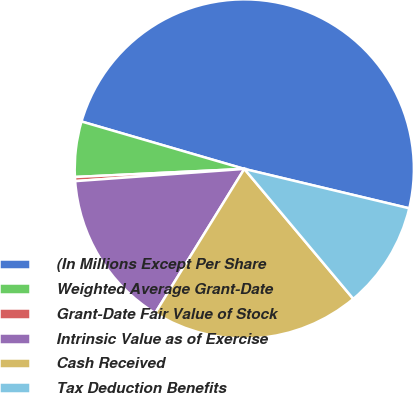<chart> <loc_0><loc_0><loc_500><loc_500><pie_chart><fcel>(In Millions Except Per Share<fcel>Weighted Average Grant-Date<fcel>Grant-Date Fair Value of Stock<fcel>Intrinsic Value as of Exercise<fcel>Cash Received<fcel>Tax Deduction Benefits<nl><fcel>49.22%<fcel>5.27%<fcel>0.39%<fcel>15.04%<fcel>19.92%<fcel>10.16%<nl></chart> 